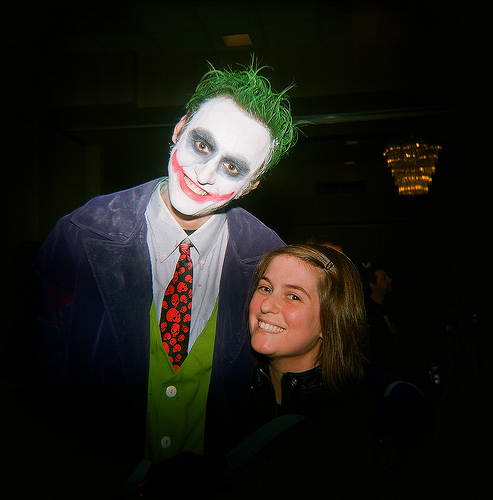<image>
Can you confirm if the man is in front of the woman? No. The man is not in front of the woman. The spatial positioning shows a different relationship between these objects. 